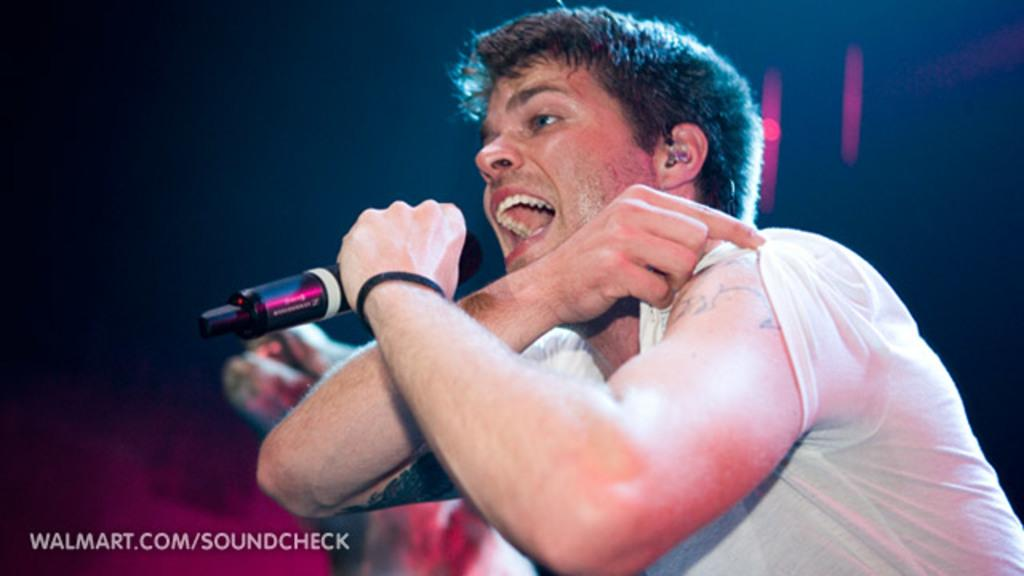What is the person in the image doing? The person is singing. What is the person wearing in the image? The person is wearing a white t-shirt. Can you describe any visible features on the person's hands? The person has a tattoo on their right hand. What object is the person holding in their left hand? The person is holding a microphone with their left hand. What type of glass is the person drinking from in the image? There is no glass present in the image; the person is holding a microphone. How many eggs are visible in the image? There are no eggs present in the image. 